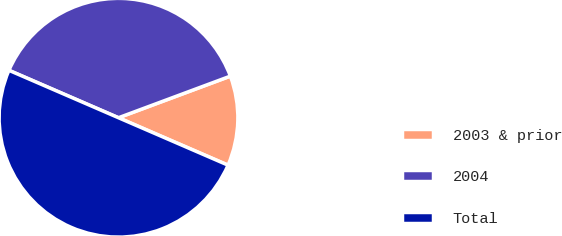<chart> <loc_0><loc_0><loc_500><loc_500><pie_chart><fcel>2003 & prior<fcel>2004<fcel>Total<nl><fcel>12.17%<fcel>37.83%<fcel>50.0%<nl></chart> 